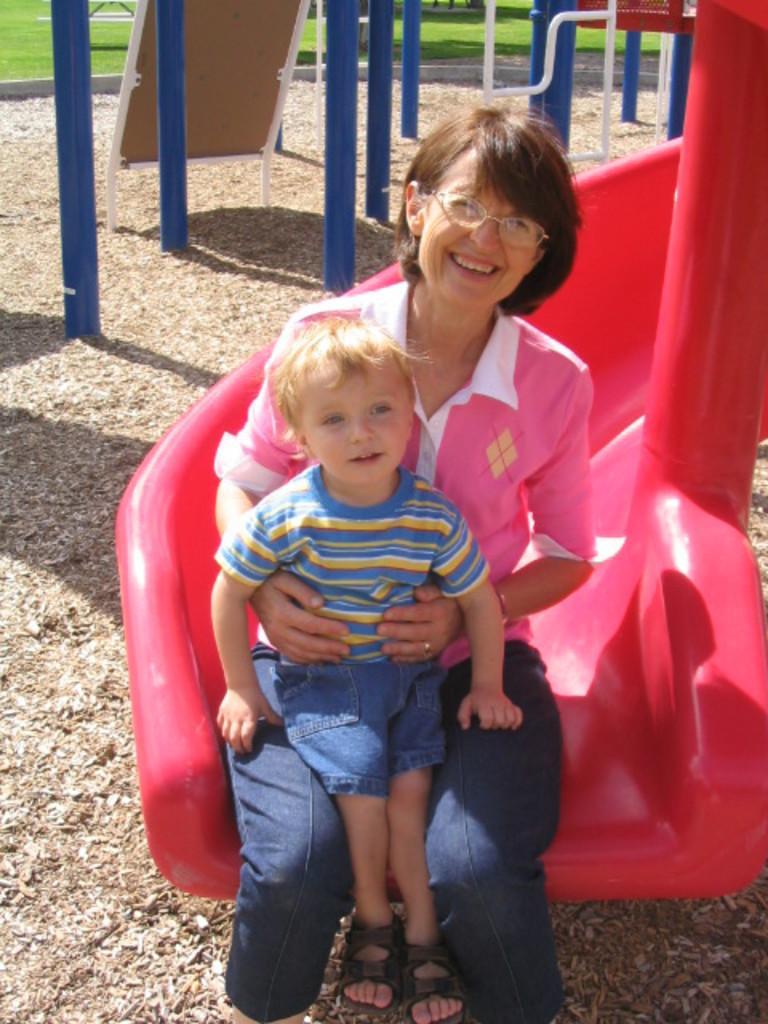Can you describe this image briefly? In the picture we can see a woman sitting on the play equipment and smiling and on her we can see a small child sitting and behind them, we can see some blue color poles and behind it we can see a grass surface. 